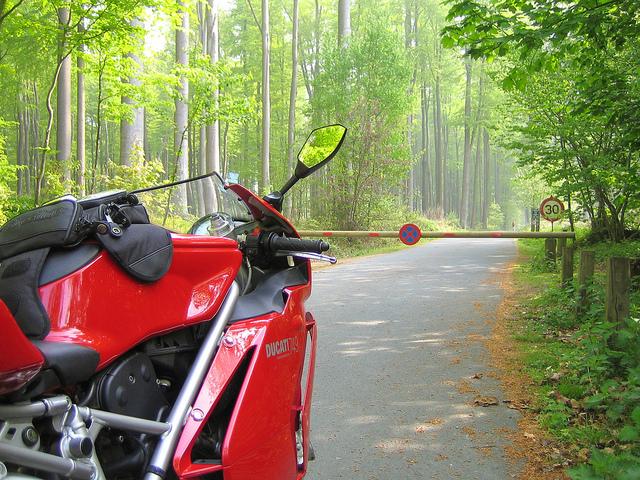Can the bike travel any further down this road?
Be succinct. No. Is anyone riding this bike in the photo?
Write a very short answer. No. Is there a mirror on the bike?
Concise answer only. Yes. 